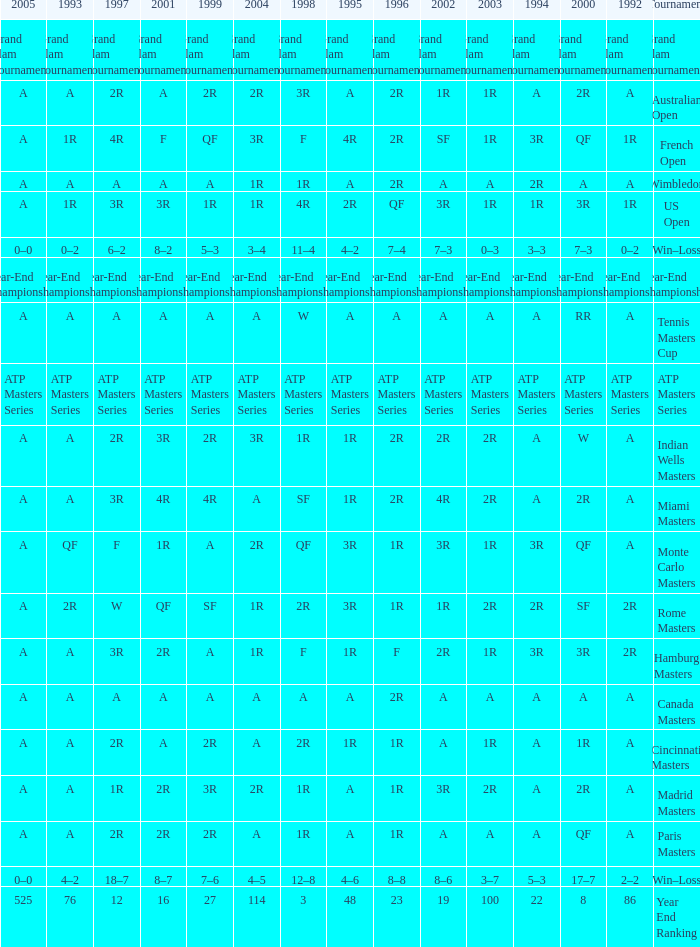What is Tournament, when 2000 is "A"? Wimbledon, Canada Masters. 